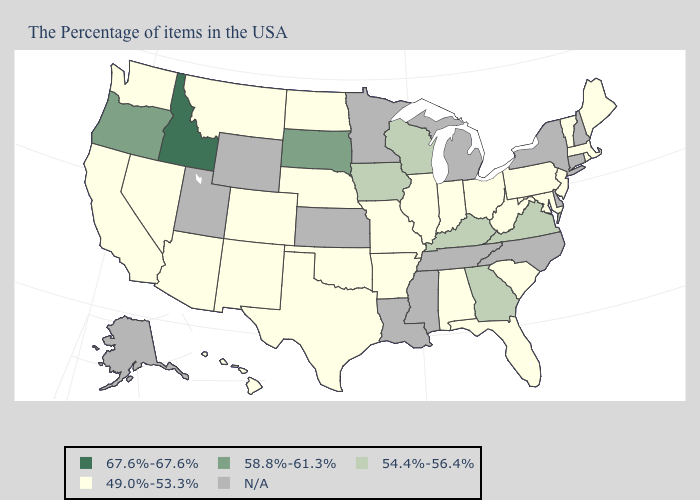What is the lowest value in the USA?
Keep it brief. 49.0%-53.3%. What is the highest value in the MidWest ?
Quick response, please. 58.8%-61.3%. What is the lowest value in the USA?
Concise answer only. 49.0%-53.3%. What is the value of Kansas?
Keep it brief. N/A. Name the states that have a value in the range 58.8%-61.3%?
Be succinct. South Dakota, Oregon. What is the value of Missouri?
Answer briefly. 49.0%-53.3%. Is the legend a continuous bar?
Short answer required. No. Which states have the lowest value in the USA?
Short answer required. Maine, Massachusetts, Rhode Island, Vermont, New Jersey, Maryland, Pennsylvania, South Carolina, West Virginia, Ohio, Florida, Indiana, Alabama, Illinois, Missouri, Arkansas, Nebraska, Oklahoma, Texas, North Dakota, Colorado, New Mexico, Montana, Arizona, Nevada, California, Washington, Hawaii. Name the states that have a value in the range 49.0%-53.3%?
Keep it brief. Maine, Massachusetts, Rhode Island, Vermont, New Jersey, Maryland, Pennsylvania, South Carolina, West Virginia, Ohio, Florida, Indiana, Alabama, Illinois, Missouri, Arkansas, Nebraska, Oklahoma, Texas, North Dakota, Colorado, New Mexico, Montana, Arizona, Nevada, California, Washington, Hawaii. What is the value of South Dakota?
Write a very short answer. 58.8%-61.3%. What is the highest value in the USA?
Be succinct. 67.6%-67.6%. Among the states that border Delaware , which have the highest value?
Be succinct. New Jersey, Maryland, Pennsylvania. What is the value of Virginia?
Concise answer only. 54.4%-56.4%. Which states have the lowest value in the MidWest?
Give a very brief answer. Ohio, Indiana, Illinois, Missouri, Nebraska, North Dakota. 